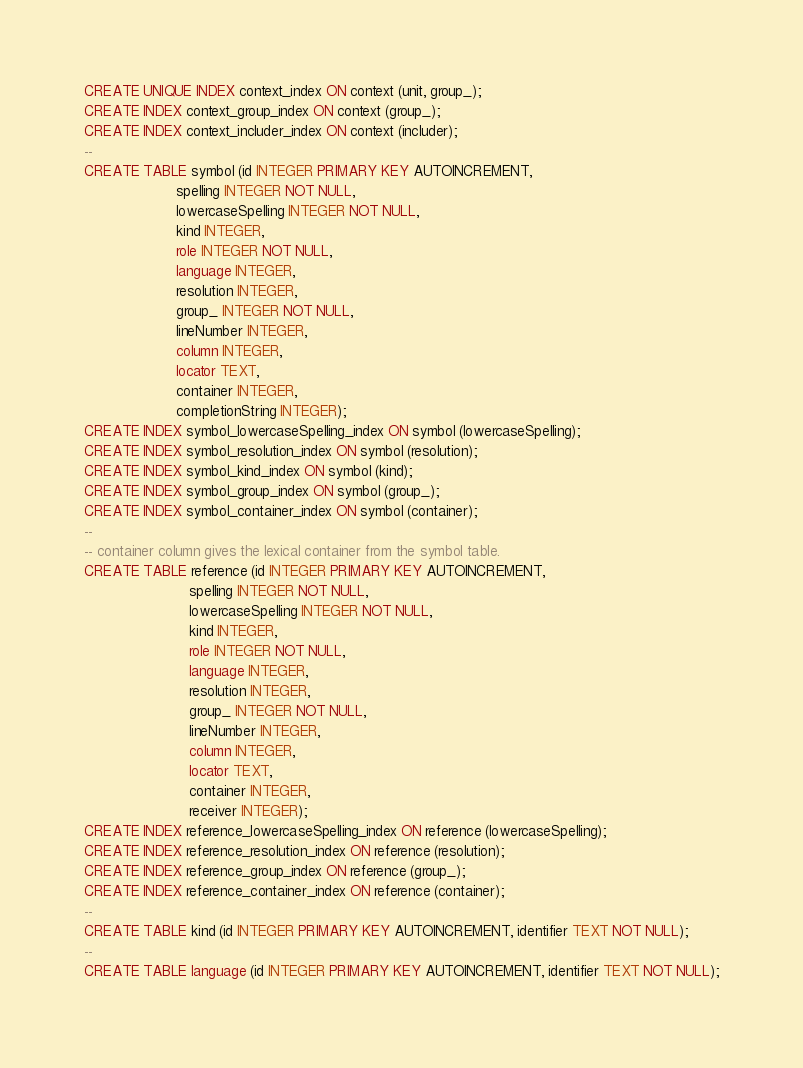<code> <loc_0><loc_0><loc_500><loc_500><_SQL_>CREATE UNIQUE INDEX context_index ON context (unit, group_);
CREATE INDEX context_group_index ON context (group_);
CREATE INDEX context_includer_index ON context (includer);
--
CREATE TABLE symbol (id INTEGER PRIMARY KEY AUTOINCREMENT,
                     spelling INTEGER NOT NULL,
                     lowercaseSpelling INTEGER NOT NULL,
                     kind INTEGER,
                     role INTEGER NOT NULL,
                     language INTEGER,
                     resolution INTEGER,
                     group_ INTEGER NOT NULL,
                     lineNumber INTEGER,
                     column INTEGER,
                     locator TEXT,
                     container INTEGER,
                     completionString INTEGER);
CREATE INDEX symbol_lowercaseSpelling_index ON symbol (lowercaseSpelling);
CREATE INDEX symbol_resolution_index ON symbol (resolution);
CREATE INDEX symbol_kind_index ON symbol (kind);
CREATE INDEX symbol_group_index ON symbol (group_);
CREATE INDEX symbol_container_index ON symbol (container);
--
-- container column gives the lexical container from the symbol table.
CREATE TABLE reference (id INTEGER PRIMARY KEY AUTOINCREMENT,
                        spelling INTEGER NOT NULL,
                        lowercaseSpelling INTEGER NOT NULL,
                        kind INTEGER,
                        role INTEGER NOT NULL,
                        language INTEGER,
                        resolution INTEGER,
                        group_ INTEGER NOT NULL,
                        lineNumber INTEGER,
                        column INTEGER,
                        locator TEXT,
                        container INTEGER,
                        receiver INTEGER);
CREATE INDEX reference_lowercaseSpelling_index ON reference (lowercaseSpelling);
CREATE INDEX reference_resolution_index ON reference (resolution);
CREATE INDEX reference_group_index ON reference (group_);
CREATE INDEX reference_container_index ON reference (container);
--
CREATE TABLE kind (id INTEGER PRIMARY KEY AUTOINCREMENT, identifier TEXT NOT NULL);
--
CREATE TABLE language (id INTEGER PRIMARY KEY AUTOINCREMENT, identifier TEXT NOT NULL);
</code> 